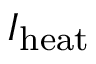<formula> <loc_0><loc_0><loc_500><loc_500>I _ { h e a t }</formula> 